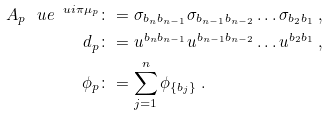<formula> <loc_0><loc_0><loc_500><loc_500>A _ { p } \, \ u e ^ { \ u i \pi \mu _ { p } } & \colon = \sigma _ { b _ { n } b _ { n - 1 } } \sigma _ { b _ { n - 1 } b _ { n - 2 } } \dots \sigma _ { b _ { 2 } b _ { 1 } } \ , \\ d _ { p } & \colon = u ^ { b _ { n } b _ { n - 1 } } u ^ { b _ { n - 1 } b _ { n - 2 } } \dots u ^ { b _ { 2 } b _ { 1 } } \ , \\ \phi _ { p } & \colon = \sum _ { j = 1 } ^ { n } \phi _ { \{ b _ { j } \} } \ .</formula> 